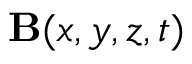Convert formula to latex. <formula><loc_0><loc_0><loc_500><loc_500>{ \mathbf B } ( x , y , z , t )</formula> 